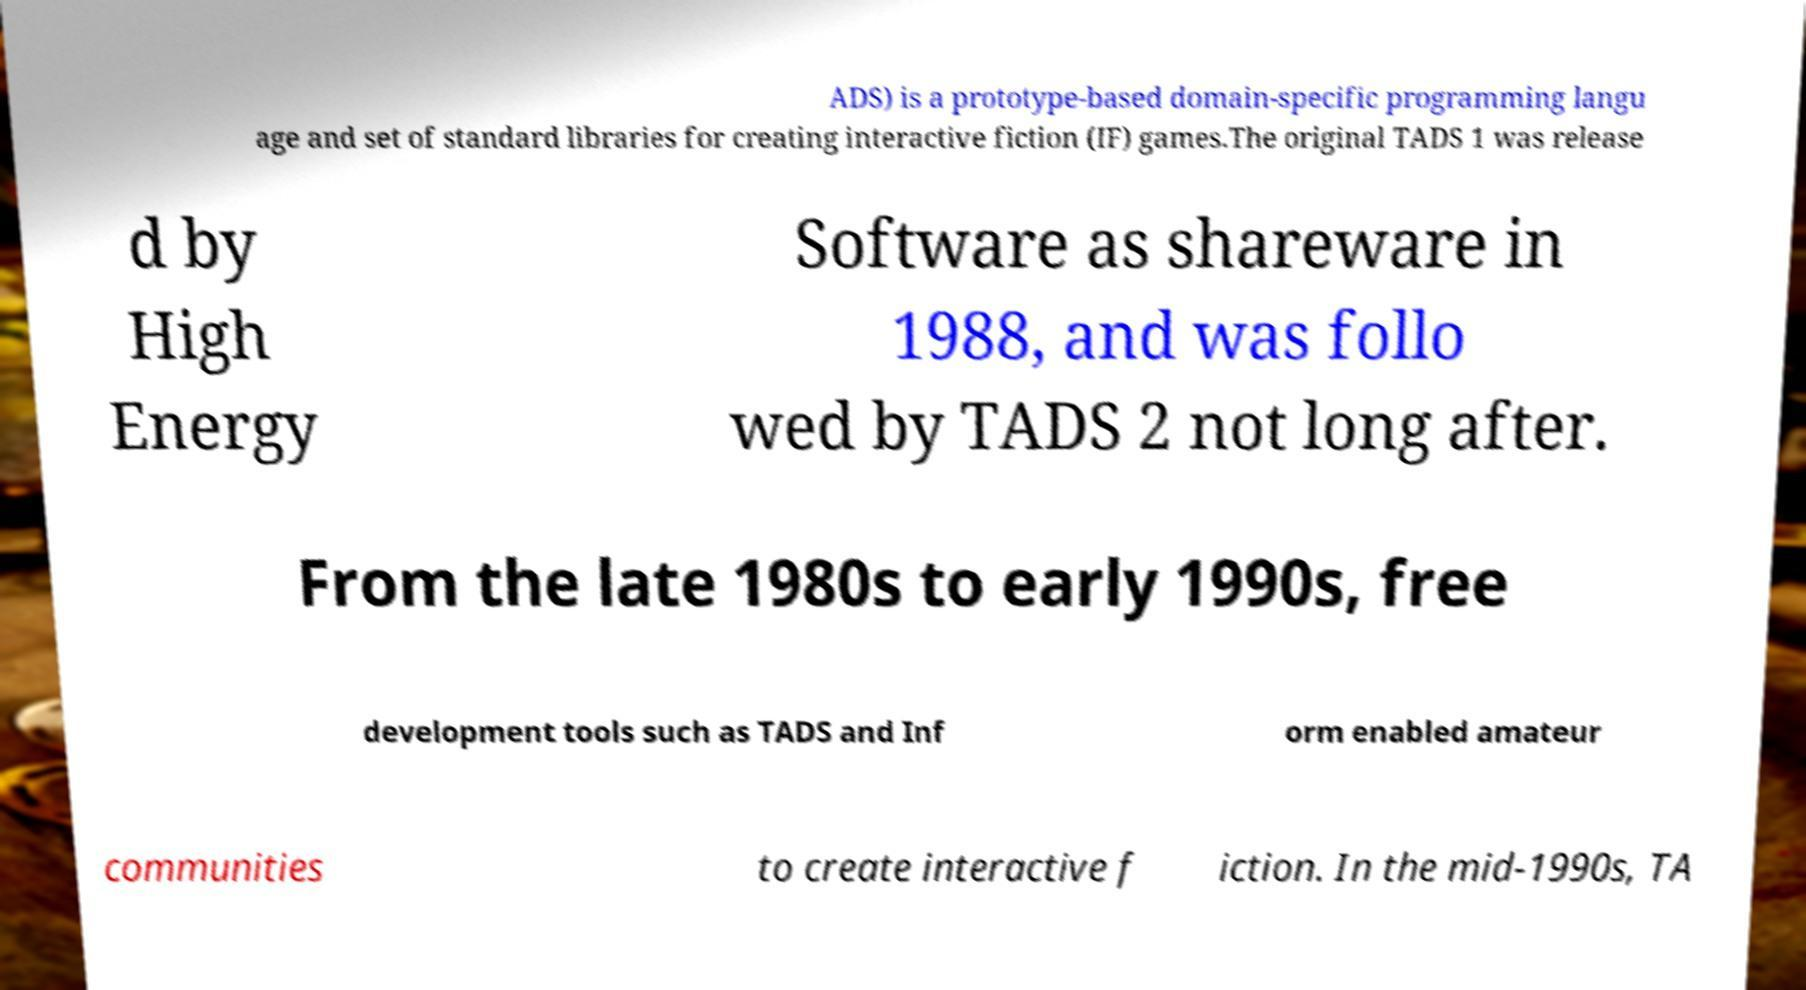For documentation purposes, I need the text within this image transcribed. Could you provide that? ADS) is a prototype-based domain-specific programming langu age and set of standard libraries for creating interactive fiction (IF) games.The original TADS 1 was release d by High Energy Software as shareware in 1988, and was follo wed by TADS 2 not long after. From the late 1980s to early 1990s, free development tools such as TADS and Inf orm enabled amateur communities to create interactive f iction. In the mid-1990s, TA 